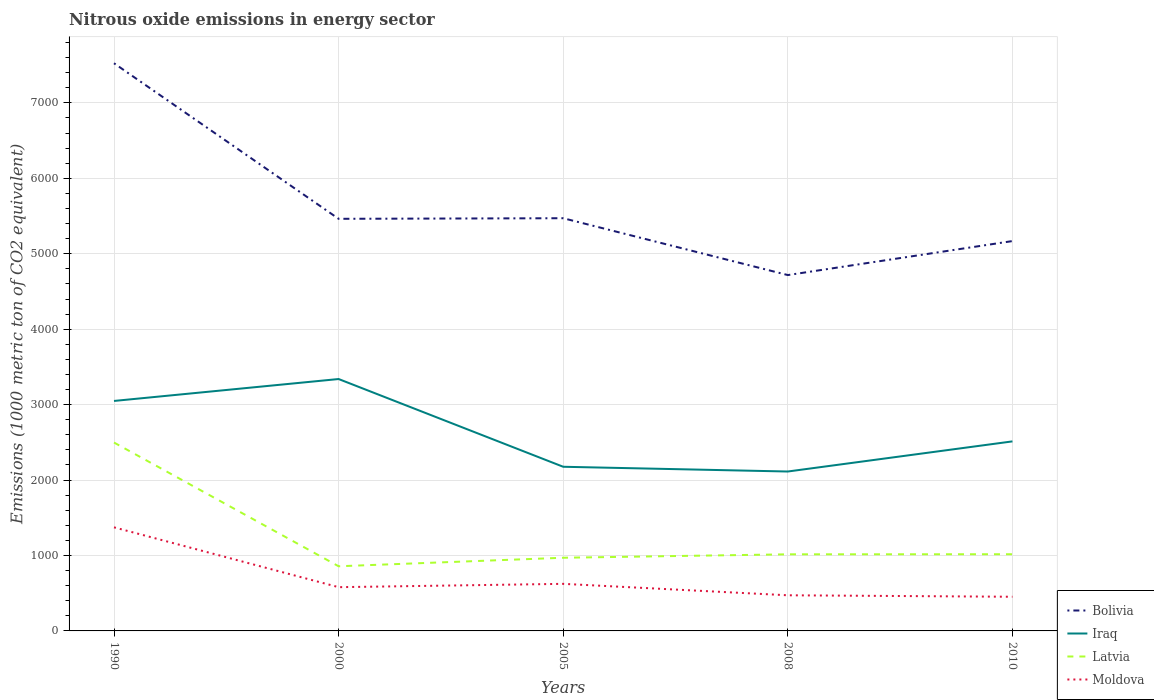Across all years, what is the maximum amount of nitrous oxide emitted in Moldova?
Ensure brevity in your answer.  452.9. What is the total amount of nitrous oxide emitted in Latvia in the graph?
Provide a short and direct response. 1480.8. What is the difference between the highest and the second highest amount of nitrous oxide emitted in Moldova?
Your answer should be very brief. 920.4. How many lines are there?
Make the answer very short. 4. Does the graph contain any zero values?
Ensure brevity in your answer.  No. Does the graph contain grids?
Provide a short and direct response. Yes. What is the title of the graph?
Your answer should be very brief. Nitrous oxide emissions in energy sector. What is the label or title of the X-axis?
Provide a succinct answer. Years. What is the label or title of the Y-axis?
Your response must be concise. Emissions (1000 metric ton of CO2 equivalent). What is the Emissions (1000 metric ton of CO2 equivalent) of Bolivia in 1990?
Offer a very short reply. 7525.2. What is the Emissions (1000 metric ton of CO2 equivalent) of Iraq in 1990?
Give a very brief answer. 3048.6. What is the Emissions (1000 metric ton of CO2 equivalent) in Latvia in 1990?
Provide a short and direct response. 2497.4. What is the Emissions (1000 metric ton of CO2 equivalent) of Moldova in 1990?
Your answer should be very brief. 1373.3. What is the Emissions (1000 metric ton of CO2 equivalent) of Bolivia in 2000?
Offer a very short reply. 5463.1. What is the Emissions (1000 metric ton of CO2 equivalent) in Iraq in 2000?
Your answer should be compact. 3339.1. What is the Emissions (1000 metric ton of CO2 equivalent) in Latvia in 2000?
Provide a short and direct response. 857.1. What is the Emissions (1000 metric ton of CO2 equivalent) of Moldova in 2000?
Your response must be concise. 579.9. What is the Emissions (1000 metric ton of CO2 equivalent) of Bolivia in 2005?
Offer a very short reply. 5470.8. What is the Emissions (1000 metric ton of CO2 equivalent) of Iraq in 2005?
Provide a succinct answer. 2176. What is the Emissions (1000 metric ton of CO2 equivalent) of Latvia in 2005?
Provide a short and direct response. 970. What is the Emissions (1000 metric ton of CO2 equivalent) of Moldova in 2005?
Offer a terse response. 624.1. What is the Emissions (1000 metric ton of CO2 equivalent) of Bolivia in 2008?
Keep it short and to the point. 4717.4. What is the Emissions (1000 metric ton of CO2 equivalent) in Iraq in 2008?
Make the answer very short. 2113.2. What is the Emissions (1000 metric ton of CO2 equivalent) in Latvia in 2008?
Provide a succinct answer. 1015.5. What is the Emissions (1000 metric ton of CO2 equivalent) of Moldova in 2008?
Ensure brevity in your answer.  472.4. What is the Emissions (1000 metric ton of CO2 equivalent) of Bolivia in 2010?
Provide a succinct answer. 5168. What is the Emissions (1000 metric ton of CO2 equivalent) of Iraq in 2010?
Keep it short and to the point. 2512.5. What is the Emissions (1000 metric ton of CO2 equivalent) in Latvia in 2010?
Offer a very short reply. 1016.6. What is the Emissions (1000 metric ton of CO2 equivalent) of Moldova in 2010?
Give a very brief answer. 452.9. Across all years, what is the maximum Emissions (1000 metric ton of CO2 equivalent) of Bolivia?
Your answer should be compact. 7525.2. Across all years, what is the maximum Emissions (1000 metric ton of CO2 equivalent) in Iraq?
Make the answer very short. 3339.1. Across all years, what is the maximum Emissions (1000 metric ton of CO2 equivalent) of Latvia?
Provide a short and direct response. 2497.4. Across all years, what is the maximum Emissions (1000 metric ton of CO2 equivalent) in Moldova?
Offer a terse response. 1373.3. Across all years, what is the minimum Emissions (1000 metric ton of CO2 equivalent) in Bolivia?
Your answer should be compact. 4717.4. Across all years, what is the minimum Emissions (1000 metric ton of CO2 equivalent) in Iraq?
Keep it short and to the point. 2113.2. Across all years, what is the minimum Emissions (1000 metric ton of CO2 equivalent) of Latvia?
Your response must be concise. 857.1. Across all years, what is the minimum Emissions (1000 metric ton of CO2 equivalent) of Moldova?
Provide a succinct answer. 452.9. What is the total Emissions (1000 metric ton of CO2 equivalent) of Bolivia in the graph?
Your answer should be very brief. 2.83e+04. What is the total Emissions (1000 metric ton of CO2 equivalent) in Iraq in the graph?
Your answer should be very brief. 1.32e+04. What is the total Emissions (1000 metric ton of CO2 equivalent) of Latvia in the graph?
Keep it short and to the point. 6356.6. What is the total Emissions (1000 metric ton of CO2 equivalent) of Moldova in the graph?
Offer a terse response. 3502.6. What is the difference between the Emissions (1000 metric ton of CO2 equivalent) of Bolivia in 1990 and that in 2000?
Make the answer very short. 2062.1. What is the difference between the Emissions (1000 metric ton of CO2 equivalent) of Iraq in 1990 and that in 2000?
Offer a terse response. -290.5. What is the difference between the Emissions (1000 metric ton of CO2 equivalent) of Latvia in 1990 and that in 2000?
Give a very brief answer. 1640.3. What is the difference between the Emissions (1000 metric ton of CO2 equivalent) in Moldova in 1990 and that in 2000?
Keep it short and to the point. 793.4. What is the difference between the Emissions (1000 metric ton of CO2 equivalent) of Bolivia in 1990 and that in 2005?
Your response must be concise. 2054.4. What is the difference between the Emissions (1000 metric ton of CO2 equivalent) of Iraq in 1990 and that in 2005?
Make the answer very short. 872.6. What is the difference between the Emissions (1000 metric ton of CO2 equivalent) of Latvia in 1990 and that in 2005?
Make the answer very short. 1527.4. What is the difference between the Emissions (1000 metric ton of CO2 equivalent) in Moldova in 1990 and that in 2005?
Your answer should be very brief. 749.2. What is the difference between the Emissions (1000 metric ton of CO2 equivalent) in Bolivia in 1990 and that in 2008?
Provide a short and direct response. 2807.8. What is the difference between the Emissions (1000 metric ton of CO2 equivalent) of Iraq in 1990 and that in 2008?
Provide a short and direct response. 935.4. What is the difference between the Emissions (1000 metric ton of CO2 equivalent) of Latvia in 1990 and that in 2008?
Provide a short and direct response. 1481.9. What is the difference between the Emissions (1000 metric ton of CO2 equivalent) in Moldova in 1990 and that in 2008?
Give a very brief answer. 900.9. What is the difference between the Emissions (1000 metric ton of CO2 equivalent) in Bolivia in 1990 and that in 2010?
Keep it short and to the point. 2357.2. What is the difference between the Emissions (1000 metric ton of CO2 equivalent) of Iraq in 1990 and that in 2010?
Provide a succinct answer. 536.1. What is the difference between the Emissions (1000 metric ton of CO2 equivalent) in Latvia in 1990 and that in 2010?
Provide a succinct answer. 1480.8. What is the difference between the Emissions (1000 metric ton of CO2 equivalent) of Moldova in 1990 and that in 2010?
Offer a terse response. 920.4. What is the difference between the Emissions (1000 metric ton of CO2 equivalent) in Iraq in 2000 and that in 2005?
Your response must be concise. 1163.1. What is the difference between the Emissions (1000 metric ton of CO2 equivalent) of Latvia in 2000 and that in 2005?
Offer a very short reply. -112.9. What is the difference between the Emissions (1000 metric ton of CO2 equivalent) of Moldova in 2000 and that in 2005?
Keep it short and to the point. -44.2. What is the difference between the Emissions (1000 metric ton of CO2 equivalent) of Bolivia in 2000 and that in 2008?
Make the answer very short. 745.7. What is the difference between the Emissions (1000 metric ton of CO2 equivalent) of Iraq in 2000 and that in 2008?
Your answer should be compact. 1225.9. What is the difference between the Emissions (1000 metric ton of CO2 equivalent) in Latvia in 2000 and that in 2008?
Your response must be concise. -158.4. What is the difference between the Emissions (1000 metric ton of CO2 equivalent) in Moldova in 2000 and that in 2008?
Offer a very short reply. 107.5. What is the difference between the Emissions (1000 metric ton of CO2 equivalent) in Bolivia in 2000 and that in 2010?
Your response must be concise. 295.1. What is the difference between the Emissions (1000 metric ton of CO2 equivalent) of Iraq in 2000 and that in 2010?
Ensure brevity in your answer.  826.6. What is the difference between the Emissions (1000 metric ton of CO2 equivalent) of Latvia in 2000 and that in 2010?
Provide a succinct answer. -159.5. What is the difference between the Emissions (1000 metric ton of CO2 equivalent) in Moldova in 2000 and that in 2010?
Keep it short and to the point. 127. What is the difference between the Emissions (1000 metric ton of CO2 equivalent) of Bolivia in 2005 and that in 2008?
Offer a very short reply. 753.4. What is the difference between the Emissions (1000 metric ton of CO2 equivalent) of Iraq in 2005 and that in 2008?
Provide a succinct answer. 62.8. What is the difference between the Emissions (1000 metric ton of CO2 equivalent) in Latvia in 2005 and that in 2008?
Offer a terse response. -45.5. What is the difference between the Emissions (1000 metric ton of CO2 equivalent) in Moldova in 2005 and that in 2008?
Make the answer very short. 151.7. What is the difference between the Emissions (1000 metric ton of CO2 equivalent) of Bolivia in 2005 and that in 2010?
Provide a succinct answer. 302.8. What is the difference between the Emissions (1000 metric ton of CO2 equivalent) of Iraq in 2005 and that in 2010?
Offer a very short reply. -336.5. What is the difference between the Emissions (1000 metric ton of CO2 equivalent) in Latvia in 2005 and that in 2010?
Offer a very short reply. -46.6. What is the difference between the Emissions (1000 metric ton of CO2 equivalent) in Moldova in 2005 and that in 2010?
Your answer should be compact. 171.2. What is the difference between the Emissions (1000 metric ton of CO2 equivalent) in Bolivia in 2008 and that in 2010?
Offer a very short reply. -450.6. What is the difference between the Emissions (1000 metric ton of CO2 equivalent) in Iraq in 2008 and that in 2010?
Offer a terse response. -399.3. What is the difference between the Emissions (1000 metric ton of CO2 equivalent) in Bolivia in 1990 and the Emissions (1000 metric ton of CO2 equivalent) in Iraq in 2000?
Offer a very short reply. 4186.1. What is the difference between the Emissions (1000 metric ton of CO2 equivalent) of Bolivia in 1990 and the Emissions (1000 metric ton of CO2 equivalent) of Latvia in 2000?
Offer a terse response. 6668.1. What is the difference between the Emissions (1000 metric ton of CO2 equivalent) in Bolivia in 1990 and the Emissions (1000 metric ton of CO2 equivalent) in Moldova in 2000?
Your answer should be very brief. 6945.3. What is the difference between the Emissions (1000 metric ton of CO2 equivalent) of Iraq in 1990 and the Emissions (1000 metric ton of CO2 equivalent) of Latvia in 2000?
Your answer should be very brief. 2191.5. What is the difference between the Emissions (1000 metric ton of CO2 equivalent) of Iraq in 1990 and the Emissions (1000 metric ton of CO2 equivalent) of Moldova in 2000?
Your answer should be compact. 2468.7. What is the difference between the Emissions (1000 metric ton of CO2 equivalent) of Latvia in 1990 and the Emissions (1000 metric ton of CO2 equivalent) of Moldova in 2000?
Provide a short and direct response. 1917.5. What is the difference between the Emissions (1000 metric ton of CO2 equivalent) in Bolivia in 1990 and the Emissions (1000 metric ton of CO2 equivalent) in Iraq in 2005?
Offer a very short reply. 5349.2. What is the difference between the Emissions (1000 metric ton of CO2 equivalent) in Bolivia in 1990 and the Emissions (1000 metric ton of CO2 equivalent) in Latvia in 2005?
Provide a short and direct response. 6555.2. What is the difference between the Emissions (1000 metric ton of CO2 equivalent) in Bolivia in 1990 and the Emissions (1000 metric ton of CO2 equivalent) in Moldova in 2005?
Offer a very short reply. 6901.1. What is the difference between the Emissions (1000 metric ton of CO2 equivalent) of Iraq in 1990 and the Emissions (1000 metric ton of CO2 equivalent) of Latvia in 2005?
Your answer should be very brief. 2078.6. What is the difference between the Emissions (1000 metric ton of CO2 equivalent) in Iraq in 1990 and the Emissions (1000 metric ton of CO2 equivalent) in Moldova in 2005?
Offer a terse response. 2424.5. What is the difference between the Emissions (1000 metric ton of CO2 equivalent) in Latvia in 1990 and the Emissions (1000 metric ton of CO2 equivalent) in Moldova in 2005?
Offer a terse response. 1873.3. What is the difference between the Emissions (1000 metric ton of CO2 equivalent) of Bolivia in 1990 and the Emissions (1000 metric ton of CO2 equivalent) of Iraq in 2008?
Give a very brief answer. 5412. What is the difference between the Emissions (1000 metric ton of CO2 equivalent) in Bolivia in 1990 and the Emissions (1000 metric ton of CO2 equivalent) in Latvia in 2008?
Your answer should be very brief. 6509.7. What is the difference between the Emissions (1000 metric ton of CO2 equivalent) in Bolivia in 1990 and the Emissions (1000 metric ton of CO2 equivalent) in Moldova in 2008?
Give a very brief answer. 7052.8. What is the difference between the Emissions (1000 metric ton of CO2 equivalent) in Iraq in 1990 and the Emissions (1000 metric ton of CO2 equivalent) in Latvia in 2008?
Your answer should be compact. 2033.1. What is the difference between the Emissions (1000 metric ton of CO2 equivalent) of Iraq in 1990 and the Emissions (1000 metric ton of CO2 equivalent) of Moldova in 2008?
Make the answer very short. 2576.2. What is the difference between the Emissions (1000 metric ton of CO2 equivalent) of Latvia in 1990 and the Emissions (1000 metric ton of CO2 equivalent) of Moldova in 2008?
Give a very brief answer. 2025. What is the difference between the Emissions (1000 metric ton of CO2 equivalent) of Bolivia in 1990 and the Emissions (1000 metric ton of CO2 equivalent) of Iraq in 2010?
Keep it short and to the point. 5012.7. What is the difference between the Emissions (1000 metric ton of CO2 equivalent) of Bolivia in 1990 and the Emissions (1000 metric ton of CO2 equivalent) of Latvia in 2010?
Provide a succinct answer. 6508.6. What is the difference between the Emissions (1000 metric ton of CO2 equivalent) in Bolivia in 1990 and the Emissions (1000 metric ton of CO2 equivalent) in Moldova in 2010?
Your answer should be compact. 7072.3. What is the difference between the Emissions (1000 metric ton of CO2 equivalent) in Iraq in 1990 and the Emissions (1000 metric ton of CO2 equivalent) in Latvia in 2010?
Keep it short and to the point. 2032. What is the difference between the Emissions (1000 metric ton of CO2 equivalent) in Iraq in 1990 and the Emissions (1000 metric ton of CO2 equivalent) in Moldova in 2010?
Your answer should be compact. 2595.7. What is the difference between the Emissions (1000 metric ton of CO2 equivalent) of Latvia in 1990 and the Emissions (1000 metric ton of CO2 equivalent) of Moldova in 2010?
Offer a very short reply. 2044.5. What is the difference between the Emissions (1000 metric ton of CO2 equivalent) of Bolivia in 2000 and the Emissions (1000 metric ton of CO2 equivalent) of Iraq in 2005?
Ensure brevity in your answer.  3287.1. What is the difference between the Emissions (1000 metric ton of CO2 equivalent) in Bolivia in 2000 and the Emissions (1000 metric ton of CO2 equivalent) in Latvia in 2005?
Your response must be concise. 4493.1. What is the difference between the Emissions (1000 metric ton of CO2 equivalent) of Bolivia in 2000 and the Emissions (1000 metric ton of CO2 equivalent) of Moldova in 2005?
Your response must be concise. 4839. What is the difference between the Emissions (1000 metric ton of CO2 equivalent) of Iraq in 2000 and the Emissions (1000 metric ton of CO2 equivalent) of Latvia in 2005?
Provide a succinct answer. 2369.1. What is the difference between the Emissions (1000 metric ton of CO2 equivalent) in Iraq in 2000 and the Emissions (1000 metric ton of CO2 equivalent) in Moldova in 2005?
Provide a short and direct response. 2715. What is the difference between the Emissions (1000 metric ton of CO2 equivalent) of Latvia in 2000 and the Emissions (1000 metric ton of CO2 equivalent) of Moldova in 2005?
Provide a succinct answer. 233. What is the difference between the Emissions (1000 metric ton of CO2 equivalent) in Bolivia in 2000 and the Emissions (1000 metric ton of CO2 equivalent) in Iraq in 2008?
Offer a terse response. 3349.9. What is the difference between the Emissions (1000 metric ton of CO2 equivalent) in Bolivia in 2000 and the Emissions (1000 metric ton of CO2 equivalent) in Latvia in 2008?
Keep it short and to the point. 4447.6. What is the difference between the Emissions (1000 metric ton of CO2 equivalent) in Bolivia in 2000 and the Emissions (1000 metric ton of CO2 equivalent) in Moldova in 2008?
Your response must be concise. 4990.7. What is the difference between the Emissions (1000 metric ton of CO2 equivalent) in Iraq in 2000 and the Emissions (1000 metric ton of CO2 equivalent) in Latvia in 2008?
Offer a very short reply. 2323.6. What is the difference between the Emissions (1000 metric ton of CO2 equivalent) in Iraq in 2000 and the Emissions (1000 metric ton of CO2 equivalent) in Moldova in 2008?
Give a very brief answer. 2866.7. What is the difference between the Emissions (1000 metric ton of CO2 equivalent) in Latvia in 2000 and the Emissions (1000 metric ton of CO2 equivalent) in Moldova in 2008?
Your response must be concise. 384.7. What is the difference between the Emissions (1000 metric ton of CO2 equivalent) in Bolivia in 2000 and the Emissions (1000 metric ton of CO2 equivalent) in Iraq in 2010?
Your answer should be compact. 2950.6. What is the difference between the Emissions (1000 metric ton of CO2 equivalent) in Bolivia in 2000 and the Emissions (1000 metric ton of CO2 equivalent) in Latvia in 2010?
Make the answer very short. 4446.5. What is the difference between the Emissions (1000 metric ton of CO2 equivalent) in Bolivia in 2000 and the Emissions (1000 metric ton of CO2 equivalent) in Moldova in 2010?
Offer a terse response. 5010.2. What is the difference between the Emissions (1000 metric ton of CO2 equivalent) in Iraq in 2000 and the Emissions (1000 metric ton of CO2 equivalent) in Latvia in 2010?
Offer a terse response. 2322.5. What is the difference between the Emissions (1000 metric ton of CO2 equivalent) in Iraq in 2000 and the Emissions (1000 metric ton of CO2 equivalent) in Moldova in 2010?
Provide a short and direct response. 2886.2. What is the difference between the Emissions (1000 metric ton of CO2 equivalent) in Latvia in 2000 and the Emissions (1000 metric ton of CO2 equivalent) in Moldova in 2010?
Ensure brevity in your answer.  404.2. What is the difference between the Emissions (1000 metric ton of CO2 equivalent) in Bolivia in 2005 and the Emissions (1000 metric ton of CO2 equivalent) in Iraq in 2008?
Keep it short and to the point. 3357.6. What is the difference between the Emissions (1000 metric ton of CO2 equivalent) in Bolivia in 2005 and the Emissions (1000 metric ton of CO2 equivalent) in Latvia in 2008?
Offer a very short reply. 4455.3. What is the difference between the Emissions (1000 metric ton of CO2 equivalent) of Bolivia in 2005 and the Emissions (1000 metric ton of CO2 equivalent) of Moldova in 2008?
Provide a short and direct response. 4998.4. What is the difference between the Emissions (1000 metric ton of CO2 equivalent) in Iraq in 2005 and the Emissions (1000 metric ton of CO2 equivalent) in Latvia in 2008?
Ensure brevity in your answer.  1160.5. What is the difference between the Emissions (1000 metric ton of CO2 equivalent) in Iraq in 2005 and the Emissions (1000 metric ton of CO2 equivalent) in Moldova in 2008?
Provide a short and direct response. 1703.6. What is the difference between the Emissions (1000 metric ton of CO2 equivalent) in Latvia in 2005 and the Emissions (1000 metric ton of CO2 equivalent) in Moldova in 2008?
Your response must be concise. 497.6. What is the difference between the Emissions (1000 metric ton of CO2 equivalent) of Bolivia in 2005 and the Emissions (1000 metric ton of CO2 equivalent) of Iraq in 2010?
Keep it short and to the point. 2958.3. What is the difference between the Emissions (1000 metric ton of CO2 equivalent) in Bolivia in 2005 and the Emissions (1000 metric ton of CO2 equivalent) in Latvia in 2010?
Give a very brief answer. 4454.2. What is the difference between the Emissions (1000 metric ton of CO2 equivalent) in Bolivia in 2005 and the Emissions (1000 metric ton of CO2 equivalent) in Moldova in 2010?
Your response must be concise. 5017.9. What is the difference between the Emissions (1000 metric ton of CO2 equivalent) of Iraq in 2005 and the Emissions (1000 metric ton of CO2 equivalent) of Latvia in 2010?
Provide a short and direct response. 1159.4. What is the difference between the Emissions (1000 metric ton of CO2 equivalent) of Iraq in 2005 and the Emissions (1000 metric ton of CO2 equivalent) of Moldova in 2010?
Give a very brief answer. 1723.1. What is the difference between the Emissions (1000 metric ton of CO2 equivalent) in Latvia in 2005 and the Emissions (1000 metric ton of CO2 equivalent) in Moldova in 2010?
Make the answer very short. 517.1. What is the difference between the Emissions (1000 metric ton of CO2 equivalent) of Bolivia in 2008 and the Emissions (1000 metric ton of CO2 equivalent) of Iraq in 2010?
Give a very brief answer. 2204.9. What is the difference between the Emissions (1000 metric ton of CO2 equivalent) of Bolivia in 2008 and the Emissions (1000 metric ton of CO2 equivalent) of Latvia in 2010?
Ensure brevity in your answer.  3700.8. What is the difference between the Emissions (1000 metric ton of CO2 equivalent) in Bolivia in 2008 and the Emissions (1000 metric ton of CO2 equivalent) in Moldova in 2010?
Give a very brief answer. 4264.5. What is the difference between the Emissions (1000 metric ton of CO2 equivalent) in Iraq in 2008 and the Emissions (1000 metric ton of CO2 equivalent) in Latvia in 2010?
Your answer should be compact. 1096.6. What is the difference between the Emissions (1000 metric ton of CO2 equivalent) in Iraq in 2008 and the Emissions (1000 metric ton of CO2 equivalent) in Moldova in 2010?
Offer a very short reply. 1660.3. What is the difference between the Emissions (1000 metric ton of CO2 equivalent) of Latvia in 2008 and the Emissions (1000 metric ton of CO2 equivalent) of Moldova in 2010?
Your response must be concise. 562.6. What is the average Emissions (1000 metric ton of CO2 equivalent) of Bolivia per year?
Your answer should be very brief. 5668.9. What is the average Emissions (1000 metric ton of CO2 equivalent) of Iraq per year?
Your response must be concise. 2637.88. What is the average Emissions (1000 metric ton of CO2 equivalent) of Latvia per year?
Provide a short and direct response. 1271.32. What is the average Emissions (1000 metric ton of CO2 equivalent) of Moldova per year?
Keep it short and to the point. 700.52. In the year 1990, what is the difference between the Emissions (1000 metric ton of CO2 equivalent) in Bolivia and Emissions (1000 metric ton of CO2 equivalent) in Iraq?
Ensure brevity in your answer.  4476.6. In the year 1990, what is the difference between the Emissions (1000 metric ton of CO2 equivalent) of Bolivia and Emissions (1000 metric ton of CO2 equivalent) of Latvia?
Provide a succinct answer. 5027.8. In the year 1990, what is the difference between the Emissions (1000 metric ton of CO2 equivalent) in Bolivia and Emissions (1000 metric ton of CO2 equivalent) in Moldova?
Provide a short and direct response. 6151.9. In the year 1990, what is the difference between the Emissions (1000 metric ton of CO2 equivalent) in Iraq and Emissions (1000 metric ton of CO2 equivalent) in Latvia?
Give a very brief answer. 551.2. In the year 1990, what is the difference between the Emissions (1000 metric ton of CO2 equivalent) of Iraq and Emissions (1000 metric ton of CO2 equivalent) of Moldova?
Offer a terse response. 1675.3. In the year 1990, what is the difference between the Emissions (1000 metric ton of CO2 equivalent) of Latvia and Emissions (1000 metric ton of CO2 equivalent) of Moldova?
Your answer should be very brief. 1124.1. In the year 2000, what is the difference between the Emissions (1000 metric ton of CO2 equivalent) in Bolivia and Emissions (1000 metric ton of CO2 equivalent) in Iraq?
Provide a short and direct response. 2124. In the year 2000, what is the difference between the Emissions (1000 metric ton of CO2 equivalent) of Bolivia and Emissions (1000 metric ton of CO2 equivalent) of Latvia?
Give a very brief answer. 4606. In the year 2000, what is the difference between the Emissions (1000 metric ton of CO2 equivalent) in Bolivia and Emissions (1000 metric ton of CO2 equivalent) in Moldova?
Provide a succinct answer. 4883.2. In the year 2000, what is the difference between the Emissions (1000 metric ton of CO2 equivalent) of Iraq and Emissions (1000 metric ton of CO2 equivalent) of Latvia?
Your response must be concise. 2482. In the year 2000, what is the difference between the Emissions (1000 metric ton of CO2 equivalent) in Iraq and Emissions (1000 metric ton of CO2 equivalent) in Moldova?
Your response must be concise. 2759.2. In the year 2000, what is the difference between the Emissions (1000 metric ton of CO2 equivalent) in Latvia and Emissions (1000 metric ton of CO2 equivalent) in Moldova?
Ensure brevity in your answer.  277.2. In the year 2005, what is the difference between the Emissions (1000 metric ton of CO2 equivalent) of Bolivia and Emissions (1000 metric ton of CO2 equivalent) of Iraq?
Ensure brevity in your answer.  3294.8. In the year 2005, what is the difference between the Emissions (1000 metric ton of CO2 equivalent) in Bolivia and Emissions (1000 metric ton of CO2 equivalent) in Latvia?
Offer a very short reply. 4500.8. In the year 2005, what is the difference between the Emissions (1000 metric ton of CO2 equivalent) in Bolivia and Emissions (1000 metric ton of CO2 equivalent) in Moldova?
Offer a very short reply. 4846.7. In the year 2005, what is the difference between the Emissions (1000 metric ton of CO2 equivalent) in Iraq and Emissions (1000 metric ton of CO2 equivalent) in Latvia?
Give a very brief answer. 1206. In the year 2005, what is the difference between the Emissions (1000 metric ton of CO2 equivalent) of Iraq and Emissions (1000 metric ton of CO2 equivalent) of Moldova?
Keep it short and to the point. 1551.9. In the year 2005, what is the difference between the Emissions (1000 metric ton of CO2 equivalent) of Latvia and Emissions (1000 metric ton of CO2 equivalent) of Moldova?
Offer a terse response. 345.9. In the year 2008, what is the difference between the Emissions (1000 metric ton of CO2 equivalent) in Bolivia and Emissions (1000 metric ton of CO2 equivalent) in Iraq?
Give a very brief answer. 2604.2. In the year 2008, what is the difference between the Emissions (1000 metric ton of CO2 equivalent) in Bolivia and Emissions (1000 metric ton of CO2 equivalent) in Latvia?
Your answer should be compact. 3701.9. In the year 2008, what is the difference between the Emissions (1000 metric ton of CO2 equivalent) of Bolivia and Emissions (1000 metric ton of CO2 equivalent) of Moldova?
Your response must be concise. 4245. In the year 2008, what is the difference between the Emissions (1000 metric ton of CO2 equivalent) in Iraq and Emissions (1000 metric ton of CO2 equivalent) in Latvia?
Your answer should be very brief. 1097.7. In the year 2008, what is the difference between the Emissions (1000 metric ton of CO2 equivalent) in Iraq and Emissions (1000 metric ton of CO2 equivalent) in Moldova?
Your response must be concise. 1640.8. In the year 2008, what is the difference between the Emissions (1000 metric ton of CO2 equivalent) in Latvia and Emissions (1000 metric ton of CO2 equivalent) in Moldova?
Give a very brief answer. 543.1. In the year 2010, what is the difference between the Emissions (1000 metric ton of CO2 equivalent) of Bolivia and Emissions (1000 metric ton of CO2 equivalent) of Iraq?
Your answer should be compact. 2655.5. In the year 2010, what is the difference between the Emissions (1000 metric ton of CO2 equivalent) of Bolivia and Emissions (1000 metric ton of CO2 equivalent) of Latvia?
Ensure brevity in your answer.  4151.4. In the year 2010, what is the difference between the Emissions (1000 metric ton of CO2 equivalent) in Bolivia and Emissions (1000 metric ton of CO2 equivalent) in Moldova?
Your response must be concise. 4715.1. In the year 2010, what is the difference between the Emissions (1000 metric ton of CO2 equivalent) in Iraq and Emissions (1000 metric ton of CO2 equivalent) in Latvia?
Your answer should be compact. 1495.9. In the year 2010, what is the difference between the Emissions (1000 metric ton of CO2 equivalent) in Iraq and Emissions (1000 metric ton of CO2 equivalent) in Moldova?
Provide a short and direct response. 2059.6. In the year 2010, what is the difference between the Emissions (1000 metric ton of CO2 equivalent) of Latvia and Emissions (1000 metric ton of CO2 equivalent) of Moldova?
Give a very brief answer. 563.7. What is the ratio of the Emissions (1000 metric ton of CO2 equivalent) in Bolivia in 1990 to that in 2000?
Ensure brevity in your answer.  1.38. What is the ratio of the Emissions (1000 metric ton of CO2 equivalent) in Iraq in 1990 to that in 2000?
Your answer should be compact. 0.91. What is the ratio of the Emissions (1000 metric ton of CO2 equivalent) of Latvia in 1990 to that in 2000?
Your response must be concise. 2.91. What is the ratio of the Emissions (1000 metric ton of CO2 equivalent) in Moldova in 1990 to that in 2000?
Your response must be concise. 2.37. What is the ratio of the Emissions (1000 metric ton of CO2 equivalent) in Bolivia in 1990 to that in 2005?
Give a very brief answer. 1.38. What is the ratio of the Emissions (1000 metric ton of CO2 equivalent) of Iraq in 1990 to that in 2005?
Your answer should be very brief. 1.4. What is the ratio of the Emissions (1000 metric ton of CO2 equivalent) in Latvia in 1990 to that in 2005?
Your answer should be very brief. 2.57. What is the ratio of the Emissions (1000 metric ton of CO2 equivalent) in Moldova in 1990 to that in 2005?
Make the answer very short. 2.2. What is the ratio of the Emissions (1000 metric ton of CO2 equivalent) in Bolivia in 1990 to that in 2008?
Make the answer very short. 1.6. What is the ratio of the Emissions (1000 metric ton of CO2 equivalent) of Iraq in 1990 to that in 2008?
Give a very brief answer. 1.44. What is the ratio of the Emissions (1000 metric ton of CO2 equivalent) in Latvia in 1990 to that in 2008?
Ensure brevity in your answer.  2.46. What is the ratio of the Emissions (1000 metric ton of CO2 equivalent) in Moldova in 1990 to that in 2008?
Offer a terse response. 2.91. What is the ratio of the Emissions (1000 metric ton of CO2 equivalent) in Bolivia in 1990 to that in 2010?
Offer a terse response. 1.46. What is the ratio of the Emissions (1000 metric ton of CO2 equivalent) in Iraq in 1990 to that in 2010?
Ensure brevity in your answer.  1.21. What is the ratio of the Emissions (1000 metric ton of CO2 equivalent) of Latvia in 1990 to that in 2010?
Ensure brevity in your answer.  2.46. What is the ratio of the Emissions (1000 metric ton of CO2 equivalent) of Moldova in 1990 to that in 2010?
Ensure brevity in your answer.  3.03. What is the ratio of the Emissions (1000 metric ton of CO2 equivalent) in Bolivia in 2000 to that in 2005?
Your answer should be very brief. 1. What is the ratio of the Emissions (1000 metric ton of CO2 equivalent) in Iraq in 2000 to that in 2005?
Offer a terse response. 1.53. What is the ratio of the Emissions (1000 metric ton of CO2 equivalent) in Latvia in 2000 to that in 2005?
Your answer should be very brief. 0.88. What is the ratio of the Emissions (1000 metric ton of CO2 equivalent) of Moldova in 2000 to that in 2005?
Your answer should be compact. 0.93. What is the ratio of the Emissions (1000 metric ton of CO2 equivalent) of Bolivia in 2000 to that in 2008?
Give a very brief answer. 1.16. What is the ratio of the Emissions (1000 metric ton of CO2 equivalent) in Iraq in 2000 to that in 2008?
Give a very brief answer. 1.58. What is the ratio of the Emissions (1000 metric ton of CO2 equivalent) in Latvia in 2000 to that in 2008?
Offer a terse response. 0.84. What is the ratio of the Emissions (1000 metric ton of CO2 equivalent) in Moldova in 2000 to that in 2008?
Your response must be concise. 1.23. What is the ratio of the Emissions (1000 metric ton of CO2 equivalent) of Bolivia in 2000 to that in 2010?
Keep it short and to the point. 1.06. What is the ratio of the Emissions (1000 metric ton of CO2 equivalent) of Iraq in 2000 to that in 2010?
Offer a very short reply. 1.33. What is the ratio of the Emissions (1000 metric ton of CO2 equivalent) in Latvia in 2000 to that in 2010?
Make the answer very short. 0.84. What is the ratio of the Emissions (1000 metric ton of CO2 equivalent) in Moldova in 2000 to that in 2010?
Offer a terse response. 1.28. What is the ratio of the Emissions (1000 metric ton of CO2 equivalent) of Bolivia in 2005 to that in 2008?
Your response must be concise. 1.16. What is the ratio of the Emissions (1000 metric ton of CO2 equivalent) of Iraq in 2005 to that in 2008?
Your response must be concise. 1.03. What is the ratio of the Emissions (1000 metric ton of CO2 equivalent) of Latvia in 2005 to that in 2008?
Ensure brevity in your answer.  0.96. What is the ratio of the Emissions (1000 metric ton of CO2 equivalent) in Moldova in 2005 to that in 2008?
Offer a very short reply. 1.32. What is the ratio of the Emissions (1000 metric ton of CO2 equivalent) in Bolivia in 2005 to that in 2010?
Offer a very short reply. 1.06. What is the ratio of the Emissions (1000 metric ton of CO2 equivalent) in Iraq in 2005 to that in 2010?
Your response must be concise. 0.87. What is the ratio of the Emissions (1000 metric ton of CO2 equivalent) in Latvia in 2005 to that in 2010?
Give a very brief answer. 0.95. What is the ratio of the Emissions (1000 metric ton of CO2 equivalent) of Moldova in 2005 to that in 2010?
Provide a short and direct response. 1.38. What is the ratio of the Emissions (1000 metric ton of CO2 equivalent) of Bolivia in 2008 to that in 2010?
Your answer should be very brief. 0.91. What is the ratio of the Emissions (1000 metric ton of CO2 equivalent) of Iraq in 2008 to that in 2010?
Provide a succinct answer. 0.84. What is the ratio of the Emissions (1000 metric ton of CO2 equivalent) of Latvia in 2008 to that in 2010?
Your answer should be compact. 1. What is the ratio of the Emissions (1000 metric ton of CO2 equivalent) in Moldova in 2008 to that in 2010?
Offer a terse response. 1.04. What is the difference between the highest and the second highest Emissions (1000 metric ton of CO2 equivalent) of Bolivia?
Give a very brief answer. 2054.4. What is the difference between the highest and the second highest Emissions (1000 metric ton of CO2 equivalent) in Iraq?
Your response must be concise. 290.5. What is the difference between the highest and the second highest Emissions (1000 metric ton of CO2 equivalent) in Latvia?
Provide a short and direct response. 1480.8. What is the difference between the highest and the second highest Emissions (1000 metric ton of CO2 equivalent) in Moldova?
Ensure brevity in your answer.  749.2. What is the difference between the highest and the lowest Emissions (1000 metric ton of CO2 equivalent) in Bolivia?
Provide a succinct answer. 2807.8. What is the difference between the highest and the lowest Emissions (1000 metric ton of CO2 equivalent) in Iraq?
Offer a very short reply. 1225.9. What is the difference between the highest and the lowest Emissions (1000 metric ton of CO2 equivalent) of Latvia?
Provide a succinct answer. 1640.3. What is the difference between the highest and the lowest Emissions (1000 metric ton of CO2 equivalent) of Moldova?
Your answer should be very brief. 920.4. 